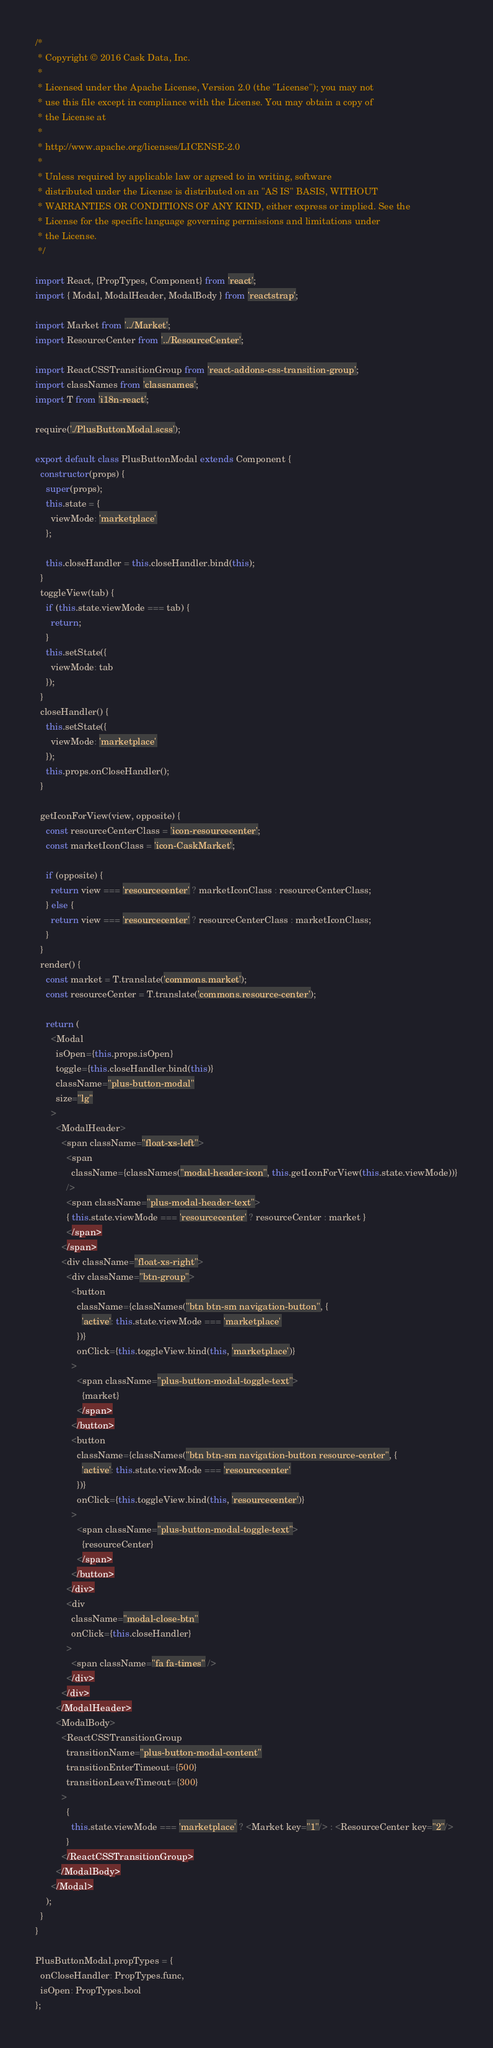<code> <loc_0><loc_0><loc_500><loc_500><_JavaScript_>/*
 * Copyright © 2016 Cask Data, Inc.
 *
 * Licensed under the Apache License, Version 2.0 (the "License"); you may not
 * use this file except in compliance with the License. You may obtain a copy of
 * the License at
 *
 * http://www.apache.org/licenses/LICENSE-2.0
 *
 * Unless required by applicable law or agreed to in writing, software
 * distributed under the License is distributed on an "AS IS" BASIS, WITHOUT
 * WARRANTIES OR CONDITIONS OF ANY KIND, either express or implied. See the
 * License for the specific language governing permissions and limitations under
 * the License.
 */

import React, {PropTypes, Component} from 'react';
import { Modal, ModalHeader, ModalBody } from 'reactstrap';

import Market from '../Market';
import ResourceCenter from '../ResourceCenter';

import ReactCSSTransitionGroup from 'react-addons-css-transition-group';
import classNames from 'classnames';
import T from 'i18n-react';

require('./PlusButtonModal.scss');

export default class PlusButtonModal extends Component {
  constructor(props) {
    super(props);
    this.state = {
      viewMode: 'marketplace'
    };

    this.closeHandler = this.closeHandler.bind(this);
  }
  toggleView(tab) {
    if (this.state.viewMode === tab) {
      return;
    }
    this.setState({
      viewMode: tab
    });
  }
  closeHandler() {
    this.setState({
      viewMode: 'marketplace'
    });
    this.props.onCloseHandler();
  }

  getIconForView(view, opposite) {
    const resourceCenterClass = 'icon-resourcecenter';
    const marketIconClass = 'icon-CaskMarket';

    if (opposite) {
      return view === 'resourcecenter' ? marketIconClass : resourceCenterClass;
    } else {
      return view === 'resourcecenter' ? resourceCenterClass : marketIconClass;
    }
  }
  render() {
    const market = T.translate('commons.market');
    const resourceCenter = T.translate('commons.resource-center');

    return (
      <Modal
        isOpen={this.props.isOpen}
        toggle={this.closeHandler.bind(this)}
        className="plus-button-modal"
        size="lg"
      >
        <ModalHeader>
          <span className="float-xs-left">
            <span
              className={classNames("modal-header-icon", this.getIconForView(this.state.viewMode))}
            />
            <span className="plus-modal-header-text">
            { this.state.viewMode === 'resourcecenter' ? resourceCenter : market }
            </span>
          </span>
          <div className="float-xs-right">
            <div className="btn-group">
              <button
                className={classNames("btn btn-sm navigation-button", {
                  'active': this.state.viewMode === 'marketplace'
                })}
                onClick={this.toggleView.bind(this, 'marketplace')}
              >
                <span className="plus-button-modal-toggle-text">
                  {market}
                </span>
              </button>
              <button
                className={classNames("btn btn-sm navigation-button resource-center", {
                  'active': this.state.viewMode === 'resourcecenter'
                })}
                onClick={this.toggleView.bind(this, 'resourcecenter')}
              >
                <span className="plus-button-modal-toggle-text">
                  {resourceCenter}
                </span>
              </button>
            </div>
            <div
              className="modal-close-btn"
              onClick={this.closeHandler}
            >
              <span className="fa fa-times" />
            </div>
          </div>
        </ModalHeader>
        <ModalBody>
          <ReactCSSTransitionGroup
            transitionName="plus-button-modal-content"
            transitionEnterTimeout={500}
            transitionLeaveTimeout={300}
          >
            {
              this.state.viewMode === 'marketplace' ? <Market key="1"/> : <ResourceCenter key="2"/>
            }
          </ReactCSSTransitionGroup>
        </ModalBody>
      </Modal>
    );
  }
}

PlusButtonModal.propTypes = {
  onCloseHandler: PropTypes.func,
  isOpen: PropTypes.bool
};
</code> 